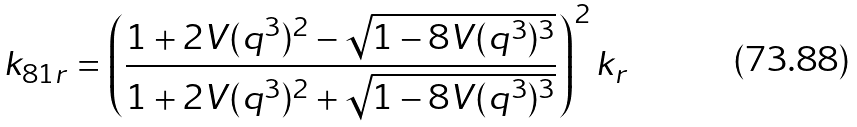Convert formula to latex. <formula><loc_0><loc_0><loc_500><loc_500>k _ { 8 1 r } = \left ( \frac { 1 + 2 V ( q ^ { 3 } ) ^ { 2 } - \sqrt { 1 - 8 V ( q ^ { 3 } ) ^ { 3 } } } { 1 + 2 V ( q ^ { 3 } ) ^ { 2 } + \sqrt { 1 - 8 V ( q ^ { 3 } ) ^ { 3 } } } \right ) ^ { 2 } k _ { r }</formula> 